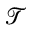<formula> <loc_0><loc_0><loc_500><loc_500>\mathcal { T }</formula> 